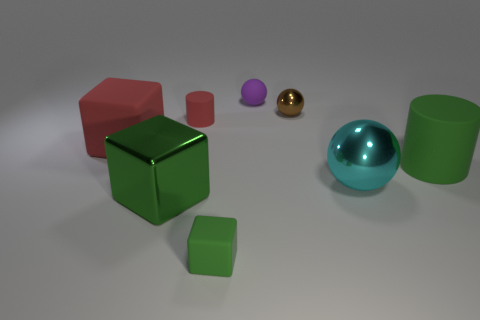Subtract all tiny balls. How many balls are left? 1 Subtract all green cubes. How many cubes are left? 1 Add 1 cyan matte objects. How many objects exist? 9 Subtract all cubes. How many objects are left? 5 Subtract 2 cylinders. How many cylinders are left? 0 Subtract all gray spheres. Subtract all green cylinders. How many spheres are left? 3 Subtract all brown spheres. How many gray blocks are left? 0 Subtract all cyan shiny spheres. Subtract all small rubber objects. How many objects are left? 4 Add 4 rubber things. How many rubber things are left? 9 Add 5 big matte cylinders. How many big matte cylinders exist? 6 